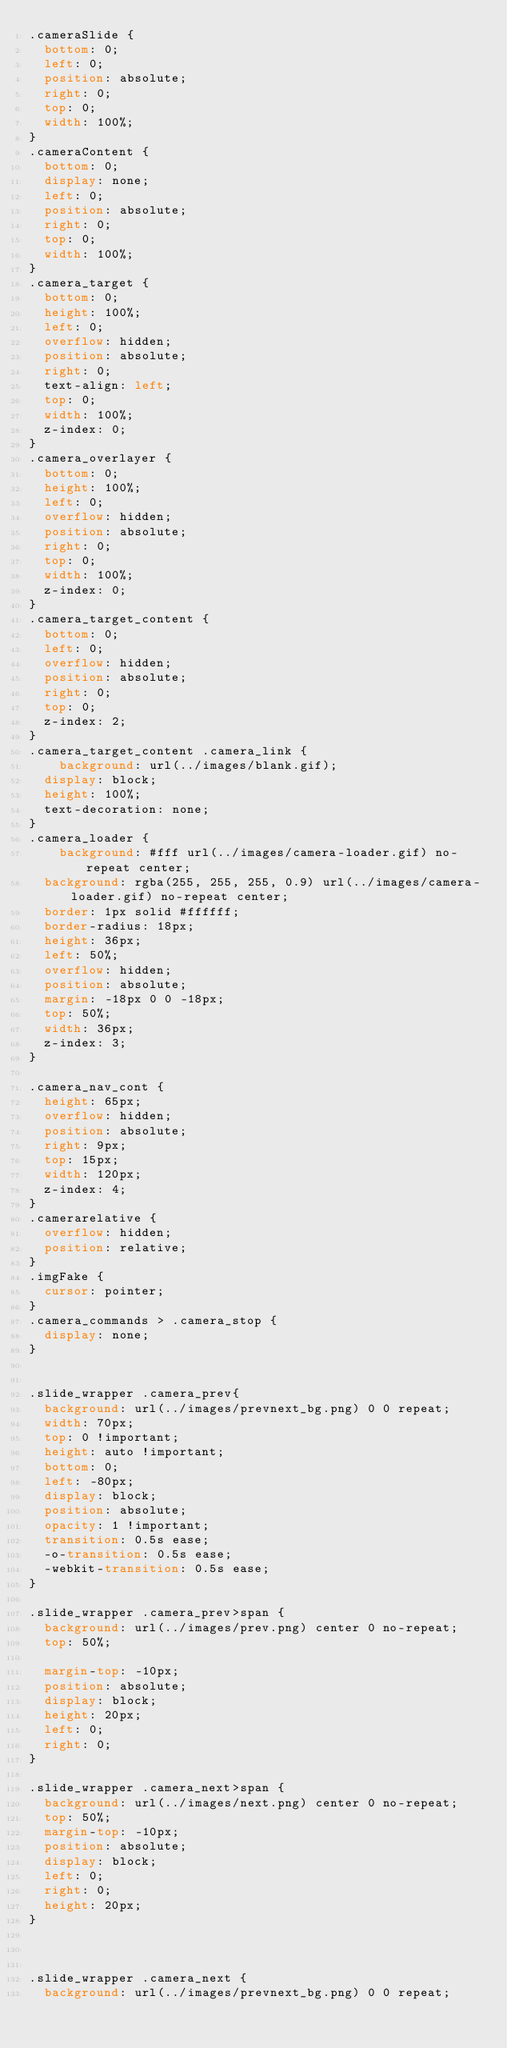<code> <loc_0><loc_0><loc_500><loc_500><_CSS_>.cameraSlide {
	bottom: 0;
	left: 0;
	position: absolute;
	right: 0;
	top: 0;
	width: 100%;
}
.cameraContent {
	bottom: 0;
	display: none;
	left: 0;
	position: absolute;
	right: 0;
	top: 0;
	width: 100%;
}
.camera_target {
	bottom: 0;
	height: 100%;
	left: 0;
	overflow: hidden;
	position: absolute;
	right: 0;
	text-align: left;
	top: 0;
	width: 100%;
	z-index: 0;
}
.camera_overlayer {
	bottom: 0;
	height: 100%;
	left: 0;
	overflow: hidden;
	position: absolute;
	right: 0;
	top: 0;
	width: 100%;
	z-index: 0;
}
.camera_target_content {
	bottom: 0;
	left: 0;
	overflow: hidden;
	position: absolute;
	right: 0;
	top: 0;
	z-index: 2;
}
.camera_target_content .camera_link {
    background: url(../images/blank.gif);
	display: block;
	height: 100%;
	text-decoration: none;
}
.camera_loader {
    background: #fff url(../images/camera-loader.gif) no-repeat center;
	background: rgba(255, 255, 255, 0.9) url(../images/camera-loader.gif) no-repeat center;
	border: 1px solid #ffffff;
	border-radius: 18px;
	height: 36px;
	left: 50%;
	overflow: hidden;
	position: absolute;
	margin: -18px 0 0 -18px;
	top: 50%;
	width: 36px;
	z-index: 3;
}

.camera_nav_cont {
	height: 65px;
	overflow: hidden;
	position: absolute;
	right: 9px;
	top: 15px;
	width: 120px;
	z-index: 4;
}
.camerarelative {
	overflow: hidden;
	position: relative;
}
.imgFake {
	cursor: pointer;
}
.camera_commands > .camera_stop {
	display: none;
}


.slide_wrapper .camera_prev{
	background: url(../images/prevnext_bg.png) 0 0 repeat;
	width: 70px;
	top: 0 !important;
	height: auto !important;
	bottom: 0;
	left: -80px;
	display: block;
	position: absolute;
	opacity: 1 !important;
	transition: 0.5s ease;
	-o-transition: 0.5s ease;
	-webkit-transition: 0.5s ease;
}

.slide_wrapper .camera_prev>span {
	background: url(../images/prev.png) center 0 no-repeat;
	top: 50%;

	margin-top: -10px;
	position: absolute;
	display: block;
	height: 20px;
	left: 0;
	right: 0;
}

.slide_wrapper .camera_next>span {
	background: url(../images/next.png) center 0 no-repeat;
	top: 50%;
	margin-top: -10px;
	position: absolute;
	display: block;
	left: 0;
	right: 0;
	height: 20px;
}



.slide_wrapper .camera_next {
	background: url(../images/prevnext_bg.png) 0 0 repeat;</code> 